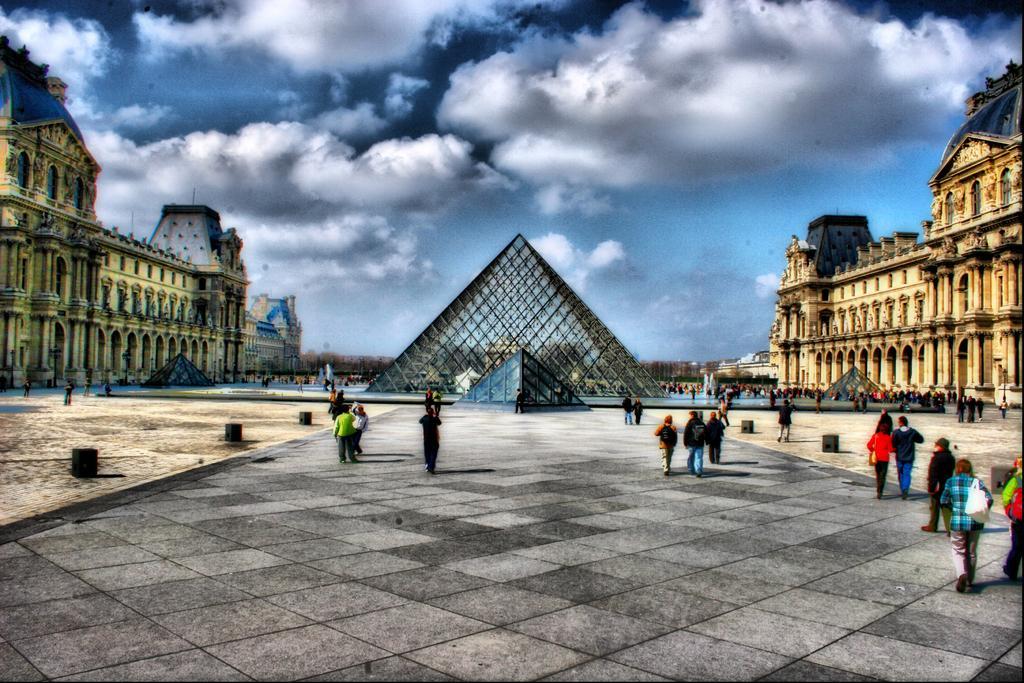Describe this image in one or two sentences. In this image there are few people walking, in front of them there is a prism structure, on the either side of the prism there are buildings, at the top of the image there are clouds in the sky. 